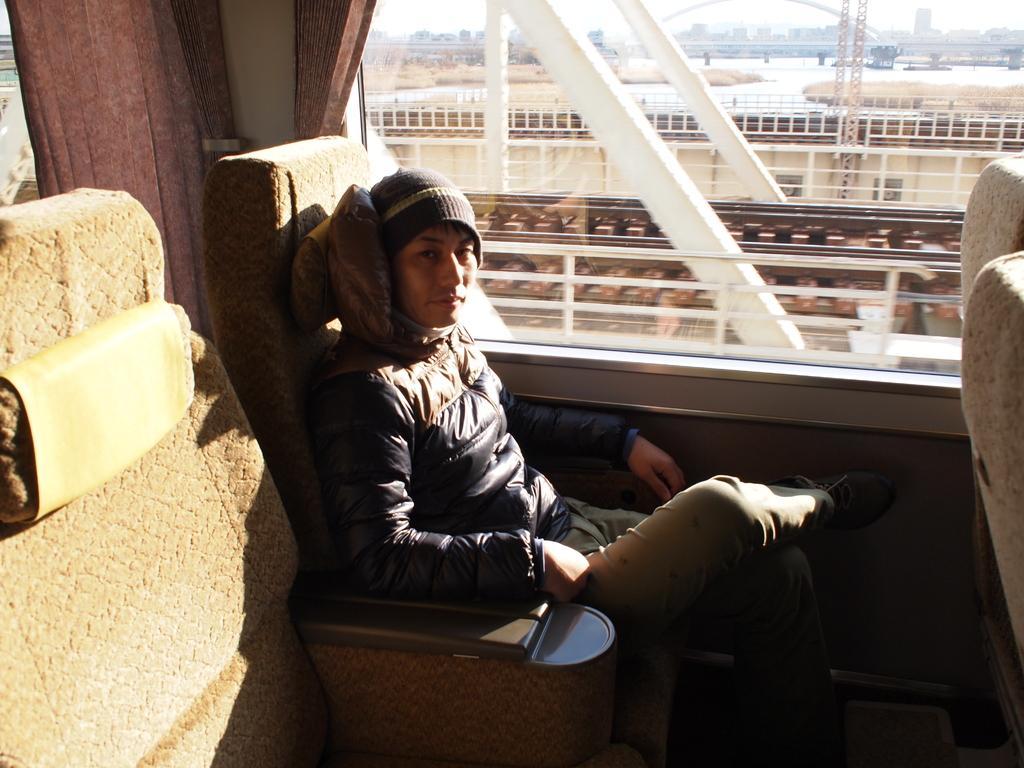Describe this image in one or two sentences. In this picture there is a man sitting in the train. At the back there is a curtain and window. Behind the window there are railway tracks, poles, buildings, trees and there is a bridge. At the top there is sky. At the bottom there is water. 